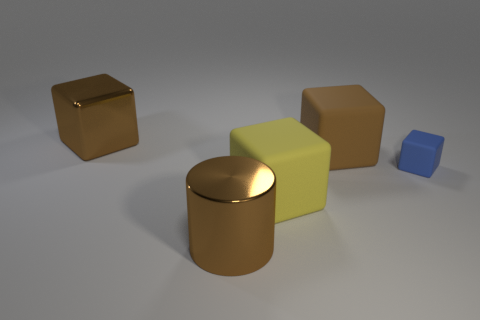Subtract all brown blocks. How many were subtracted if there are1brown blocks left? 1 Subtract all brown matte cubes. How many cubes are left? 3 Add 3 big yellow blocks. How many objects exist? 8 Subtract all blue blocks. How many blocks are left? 3 Subtract all blue cylinders. How many yellow blocks are left? 1 Subtract all blocks. How many objects are left? 1 Subtract 1 cylinders. How many cylinders are left? 0 Subtract all purple blocks. Subtract all blue spheres. How many blocks are left? 4 Subtract all rubber spheres. Subtract all matte objects. How many objects are left? 2 Add 3 rubber cubes. How many rubber cubes are left? 6 